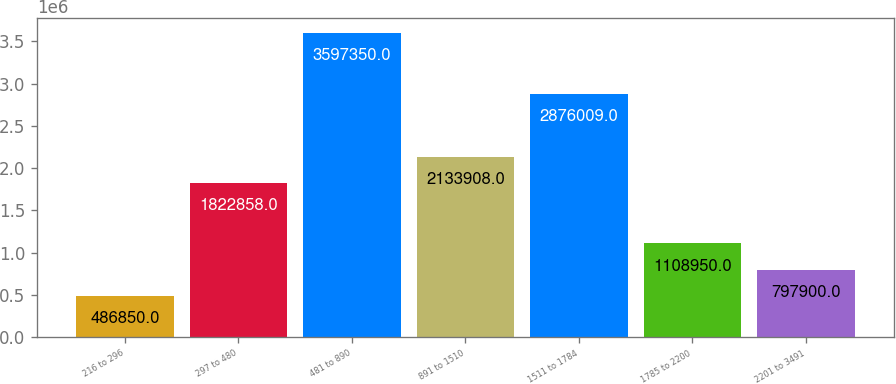Convert chart to OTSL. <chart><loc_0><loc_0><loc_500><loc_500><bar_chart><fcel>216 to 296<fcel>297 to 480<fcel>481 to 890<fcel>891 to 1510<fcel>1511 to 1784<fcel>1785 to 2200<fcel>2201 to 3491<nl><fcel>486850<fcel>1.82286e+06<fcel>3.59735e+06<fcel>2.13391e+06<fcel>2.87601e+06<fcel>1.10895e+06<fcel>797900<nl></chart> 